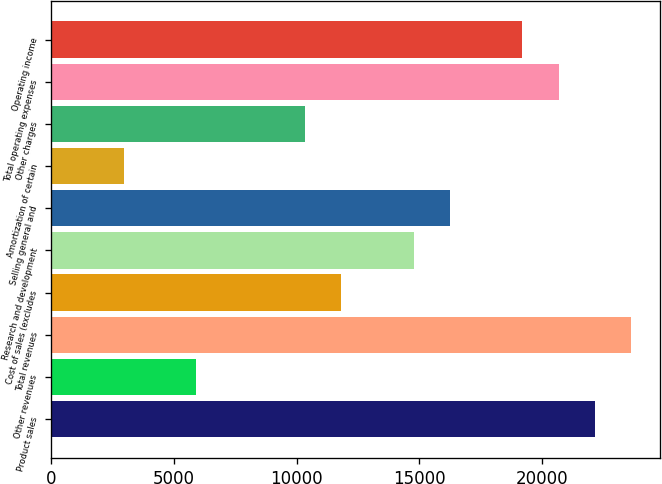Convert chart. <chart><loc_0><loc_0><loc_500><loc_500><bar_chart><fcel>Product sales<fcel>Other revenues<fcel>Total revenues<fcel>Cost of sales (excludes<fcel>Research and development<fcel>Selling general and<fcel>Amortization of certain<fcel>Other charges<fcel>Total operating expenses<fcel>Operating income<nl><fcel>22155.2<fcel>5910.06<fcel>23632<fcel>11817.4<fcel>14771<fcel>16247.9<fcel>2956.4<fcel>10340.5<fcel>20678.4<fcel>19201.5<nl></chart> 